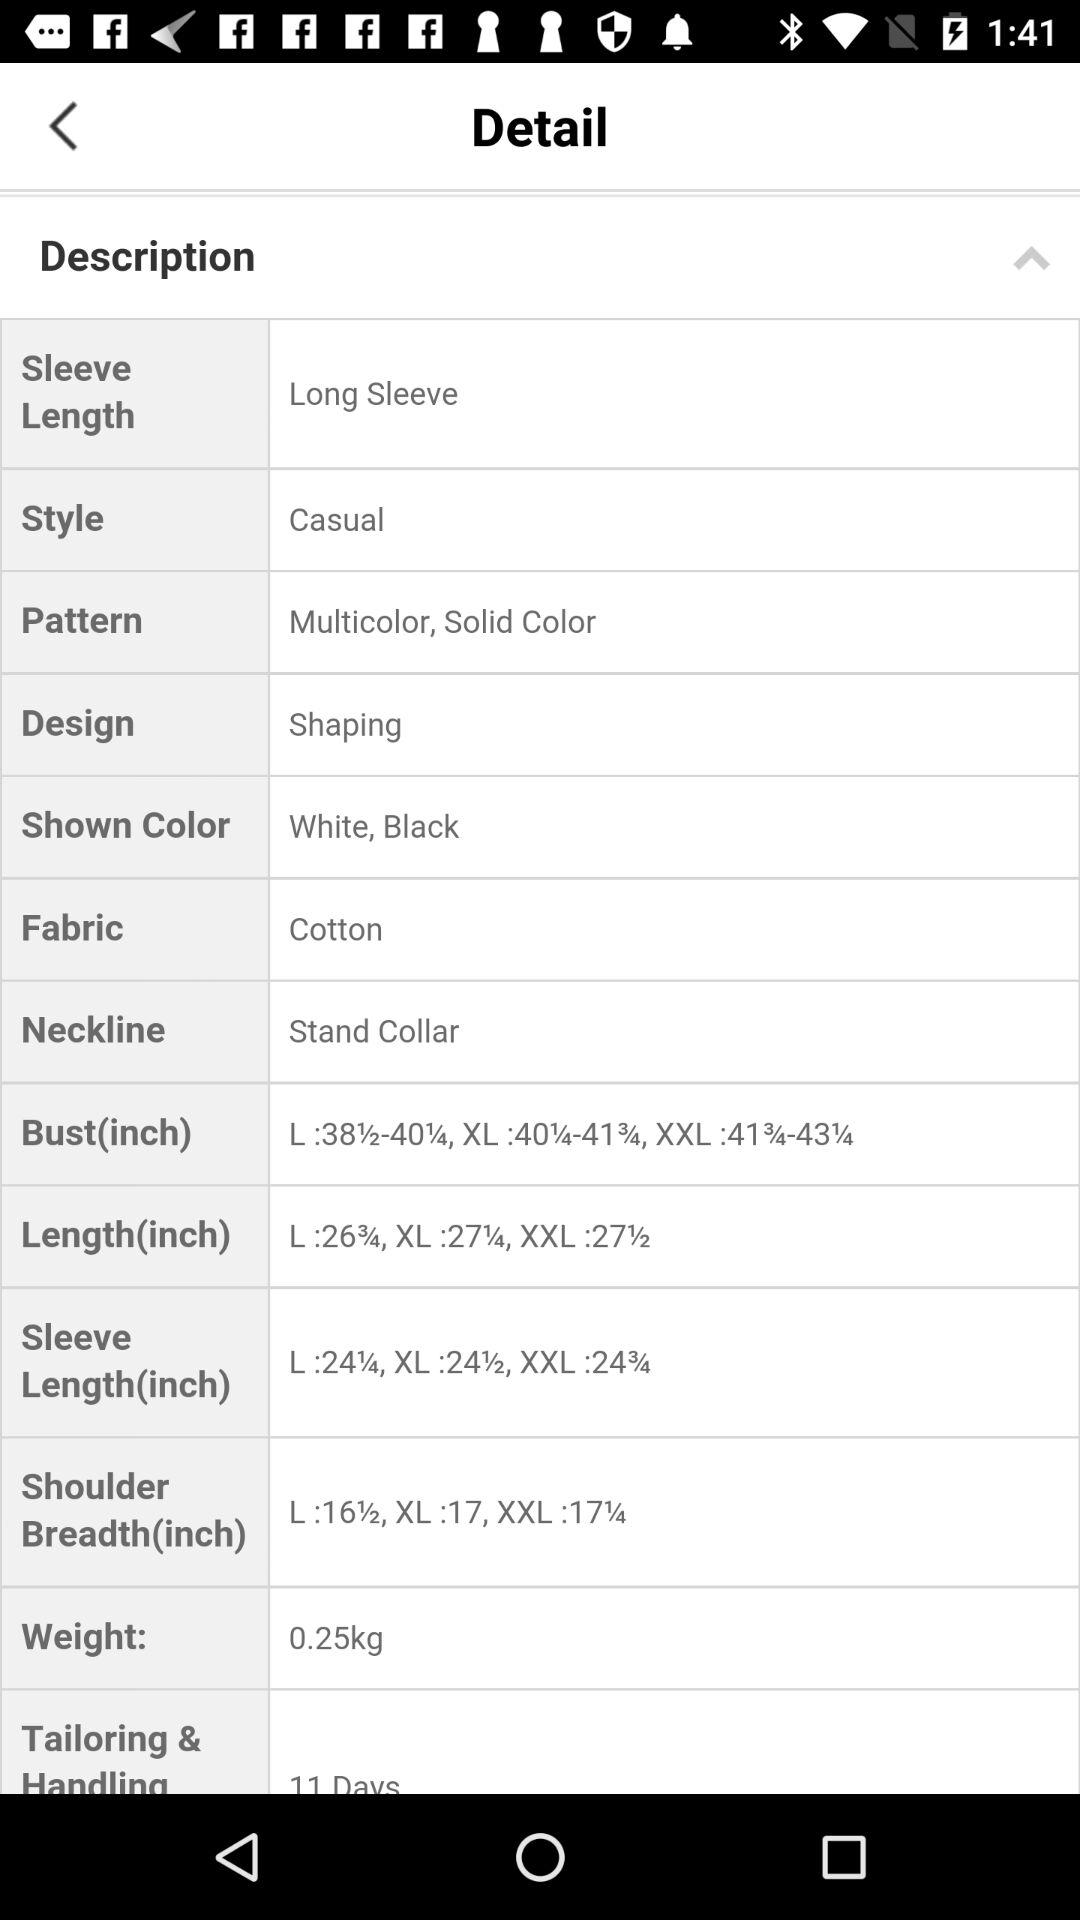What is the sleeve length? The sleeve length is "Long Sleeve". 